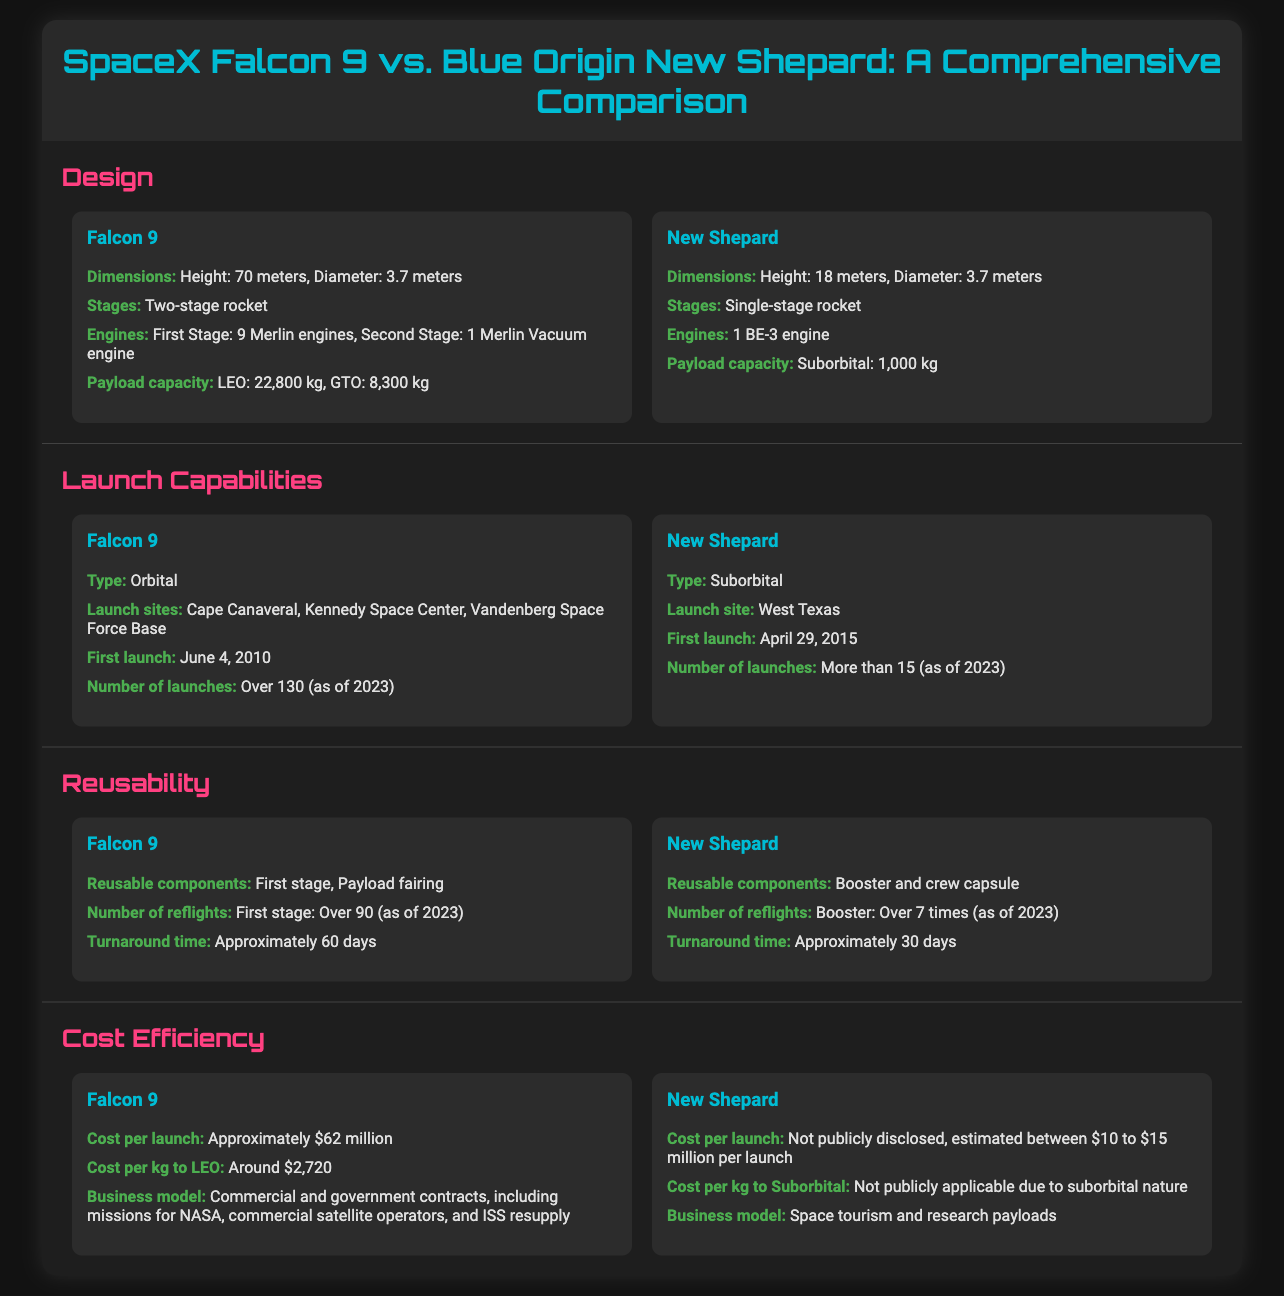what is the height of Falcon 9? The height of Falcon 9 is mentioned in the design section of the document, which states it is 70 meters.
Answer: 70 meters what is the first launch date of New Shepard? The first launch date of New Shepard is provided in the launch capabilities section, noted as April 29, 2015.
Answer: April 29, 2015 how many engines does Falcon 9 have? The design section specifies that Falcon 9 has 9 Merlin engines in the first stage and 1 Merlin Vacuum engine in the second stage, totaling 10 engines.
Answer: 10 engines which rocket has a higher payload capacity to LEO? The payload capacity to LEO is compared in the design section, where Falcon 9 has 22,800 kg while New Shepard has 1,000 kg.
Answer: Falcon 9 what is the estimated cost per launch for New Shepard? The cost per launch for New Shepard is mentioned in the cost efficiency section, estimated to be between $10 to $15 million.
Answer: $10 to $15 million how many reflights has the Falcon 9 first stage accomplished? The reusability section indicates that the Falcon 9 first stage has accomplished over 90 reflights.
Answer: Over 90 what type of rocket is New Shepard? The launch capabilities section classifies New Shepard as a suborbital rocket.
Answer: Suborbital which rocket has a longer turnaround time? The reusability section indicates that Falcon 9 has a turnaround time of approximately 60 days, while New Shepard's is about 30 days.
Answer: Falcon 9 how many launch sites does Falcon 9 utilize? The launch capabilities section lists the launch sites for Falcon 9, which are Cape Canaveral, Kennedy Space Center, and Vandenberg Space Force Base, totaling 3 sites.
Answer: 3 sites 